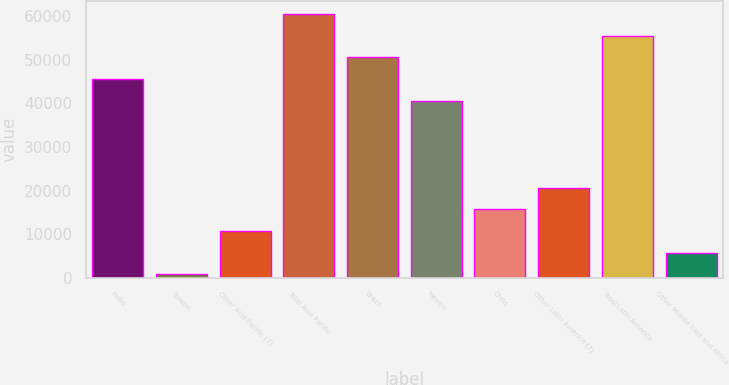Convert chart to OTSL. <chart><loc_0><loc_0><loc_500><loc_500><bar_chart><fcel>India<fcel>Taiwan<fcel>Other Asia Pacific (7)<fcel>Total Asia Pacific<fcel>Brazil<fcel>Mexico<fcel>Chile<fcel>Other Latin America (7)<fcel>Total Latin America<fcel>Other Middle East and Africa<nl><fcel>45589.5<fcel>729<fcel>10698<fcel>60543<fcel>50574<fcel>40605<fcel>15682.5<fcel>20667<fcel>55558.5<fcel>5713.5<nl></chart> 